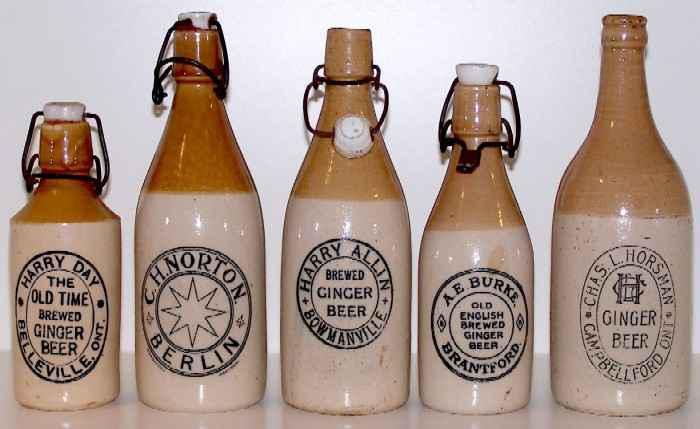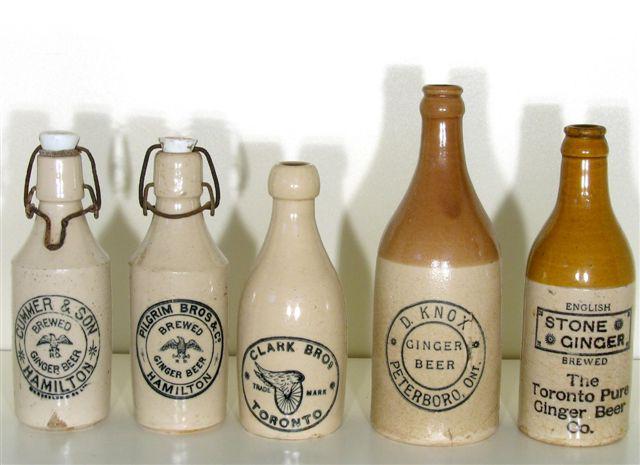The first image is the image on the left, the second image is the image on the right. For the images displayed, is the sentence "There are more than 8 bottles." factually correct? Answer yes or no. Yes. The first image is the image on the left, the second image is the image on the right. Given the left and right images, does the statement "There is no less than nine bottles." hold true? Answer yes or no. Yes. 